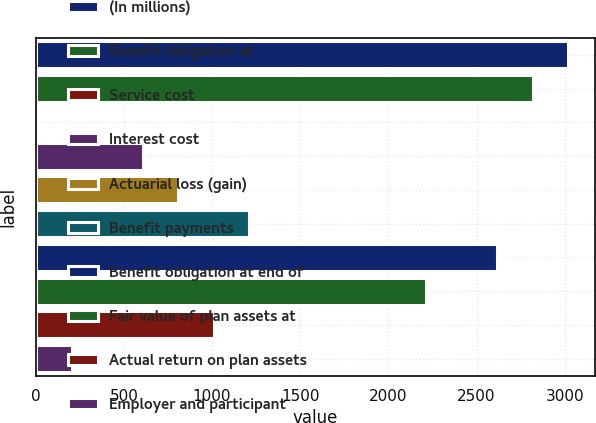<chart> <loc_0><loc_0><loc_500><loc_500><bar_chart><fcel>(In millions)<fcel>Benefit obligation at<fcel>Service cost<fcel>Interest cost<fcel>Actuarial loss (gain)<fcel>Benefit payments<fcel>Benefit obligation at end of<fcel>Fair value of plan assets at<fcel>Actual return on plan assets<fcel>Employer and participant<nl><fcel>3019<fcel>2818<fcel>4<fcel>607<fcel>808<fcel>1210<fcel>2617<fcel>2215<fcel>1009<fcel>205<nl></chart> 